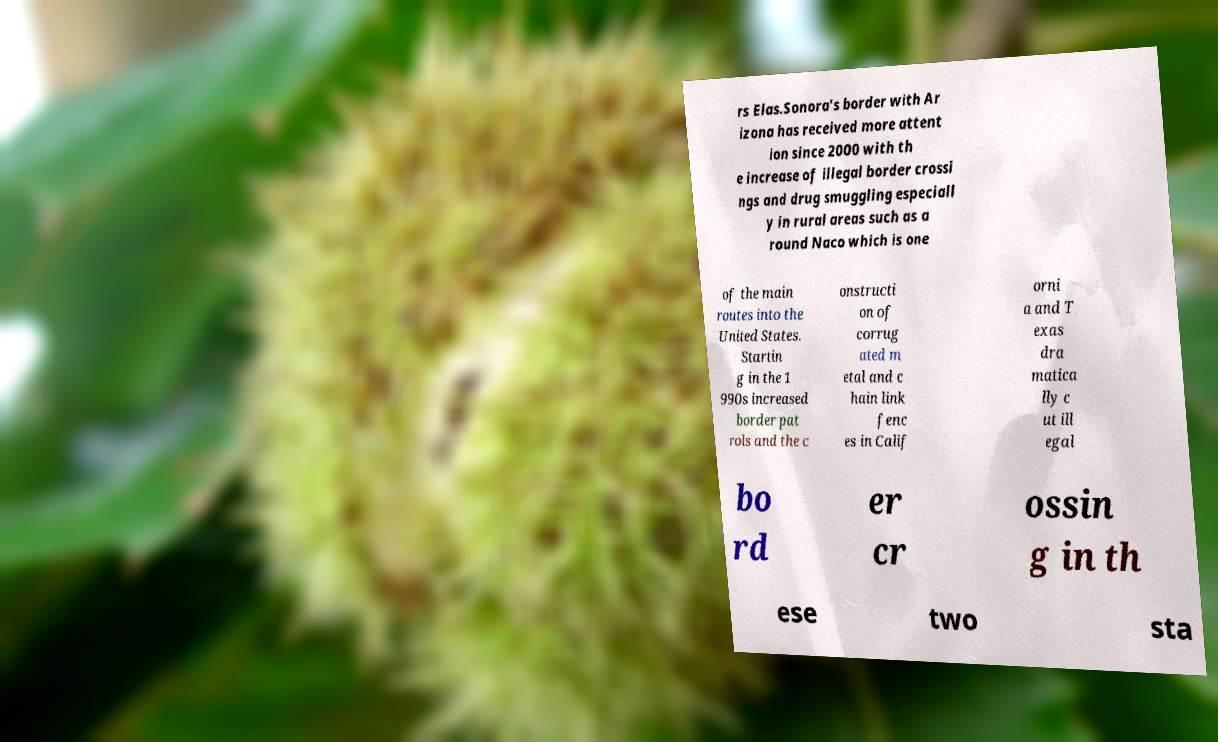Please identify and transcribe the text found in this image. rs Elas.Sonora's border with Ar izona has received more attent ion since 2000 with th e increase of illegal border crossi ngs and drug smuggling especiall y in rural areas such as a round Naco which is one of the main routes into the United States. Startin g in the 1 990s increased border pat rols and the c onstructi on of corrug ated m etal and c hain link fenc es in Calif orni a and T exas dra matica lly c ut ill egal bo rd er cr ossin g in th ese two sta 